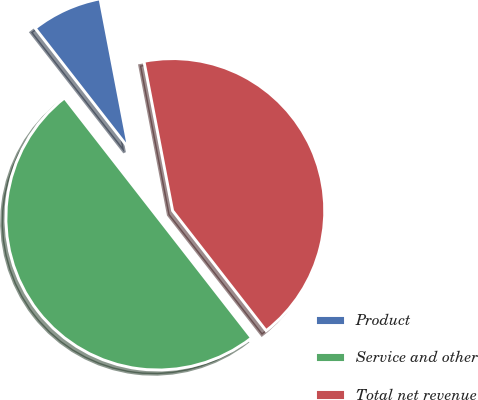Convert chart. <chart><loc_0><loc_0><loc_500><loc_500><pie_chart><fcel>Product<fcel>Service and other<fcel>Total net revenue<nl><fcel>7.52%<fcel>50.0%<fcel>42.48%<nl></chart> 